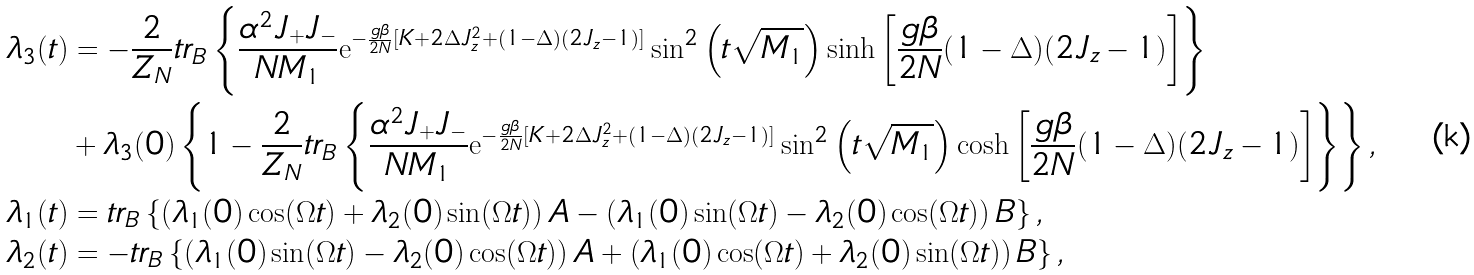<formula> <loc_0><loc_0><loc_500><loc_500>\lambda _ { 3 } ( t ) & = - \frac { 2 } { Z _ { N } } t r _ { B } \left \{ \frac { \alpha ^ { 2 } J _ { + } J _ { - } } { N M _ { 1 } } \mathrm e ^ { - \frac { g \beta } { 2 N } [ K + 2 \Delta J _ { z } ^ { 2 } + ( 1 - \Delta ) ( 2 J _ { z } - 1 ) ] } \sin ^ { 2 } \left ( t \sqrt { M _ { 1 } } \right ) \sinh \left [ \frac { g \beta } { 2 N } ( 1 - \Delta ) ( 2 J _ { z } - 1 ) \right ] \right \} \\ & + \lambda _ { 3 } ( 0 ) \left \{ 1 - \frac { 2 } { Z _ { N } } t r _ { B } \left \{ \frac { \alpha ^ { 2 } J _ { + } J _ { - } } { N M _ { 1 } } \mathrm e ^ { - \frac { g \beta } { 2 N } [ K + 2 \Delta J _ { z } ^ { 2 } + ( 1 - \Delta ) ( 2 J _ { z } - 1 ) ] } \sin ^ { 2 } \left ( t \sqrt { M _ { 1 } } \right ) \cosh \left [ \frac { g \beta } { 2 N } ( 1 - \Delta ) ( 2 J _ { z } - 1 ) \right ] \right \} \right \} , \\ \lambda _ { 1 } ( t ) & = t r _ { B } \left \{ \left ( \lambda _ { 1 } ( 0 ) \cos ( \Omega t ) + \lambda _ { 2 } ( 0 ) \sin ( \Omega t ) \right ) A - \left ( \lambda _ { 1 } ( 0 ) \sin ( \Omega t ) - \lambda _ { 2 } ( 0 ) \cos ( \Omega t ) \right ) B \right \} , \\ \lambda _ { 2 } ( t ) & = - t r _ { B } \left \{ \left ( \lambda _ { 1 } ( 0 ) \sin ( \Omega t ) - \lambda _ { 2 } ( 0 ) \cos ( \Omega t ) \right ) A + \left ( \lambda _ { 1 } ( 0 ) \cos ( \Omega t ) + \lambda _ { 2 } ( 0 ) \sin ( \Omega t ) \right ) B \right \} ,</formula> 